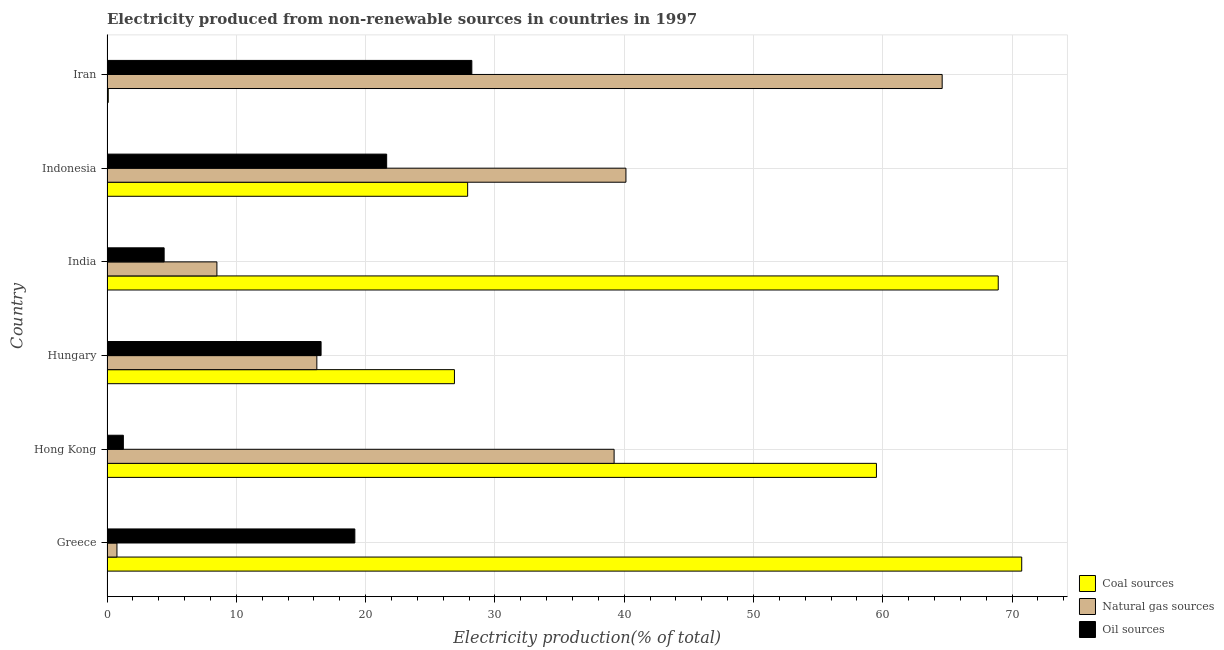Are the number of bars per tick equal to the number of legend labels?
Provide a short and direct response. Yes. Are the number of bars on each tick of the Y-axis equal?
Keep it short and to the point. Yes. How many bars are there on the 5th tick from the top?
Your answer should be compact. 3. How many bars are there on the 3rd tick from the bottom?
Provide a short and direct response. 3. What is the percentage of electricity produced by oil sources in Iran?
Your response must be concise. 28.22. Across all countries, what is the maximum percentage of electricity produced by natural gas?
Ensure brevity in your answer.  64.6. Across all countries, what is the minimum percentage of electricity produced by oil sources?
Give a very brief answer. 1.26. In which country was the percentage of electricity produced by coal maximum?
Offer a terse response. Greece. In which country was the percentage of electricity produced by natural gas minimum?
Provide a succinct answer. Greece. What is the total percentage of electricity produced by coal in the graph?
Make the answer very short. 254.06. What is the difference between the percentage of electricity produced by coal in Hong Kong and that in Iran?
Offer a very short reply. 59.41. What is the difference between the percentage of electricity produced by natural gas in Iran and the percentage of electricity produced by coal in India?
Provide a succinct answer. -4.34. What is the average percentage of electricity produced by oil sources per country?
Your response must be concise. 15.21. What is the difference between the percentage of electricity produced by natural gas and percentage of electricity produced by coal in Greece?
Your answer should be compact. -69.98. What is the ratio of the percentage of electricity produced by coal in Greece to that in Hungary?
Give a very brief answer. 2.63. Is the percentage of electricity produced by natural gas in Hong Kong less than that in Indonesia?
Make the answer very short. Yes. Is the difference between the percentage of electricity produced by oil sources in Hungary and Iran greater than the difference between the percentage of electricity produced by coal in Hungary and Iran?
Your response must be concise. No. What is the difference between the highest and the second highest percentage of electricity produced by oil sources?
Make the answer very short. 6.59. What is the difference between the highest and the lowest percentage of electricity produced by oil sources?
Give a very brief answer. 26.95. In how many countries, is the percentage of electricity produced by oil sources greater than the average percentage of electricity produced by oil sources taken over all countries?
Keep it short and to the point. 4. What does the 3rd bar from the top in India represents?
Provide a short and direct response. Coal sources. What does the 3rd bar from the bottom in Indonesia represents?
Provide a succinct answer. Oil sources. How many bars are there?
Offer a very short reply. 18. Are all the bars in the graph horizontal?
Provide a short and direct response. Yes. How many countries are there in the graph?
Give a very brief answer. 6. Are the values on the major ticks of X-axis written in scientific E-notation?
Your answer should be compact. No. Does the graph contain any zero values?
Ensure brevity in your answer.  No. How are the legend labels stacked?
Provide a succinct answer. Vertical. What is the title of the graph?
Your answer should be compact. Electricity produced from non-renewable sources in countries in 1997. Does "Hydroelectric sources" appear as one of the legend labels in the graph?
Ensure brevity in your answer.  No. What is the Electricity production(% of total) in Coal sources in Greece?
Your response must be concise. 70.75. What is the Electricity production(% of total) of Natural gas sources in Greece?
Your answer should be very brief. 0.77. What is the Electricity production(% of total) of Oil sources in Greece?
Make the answer very short. 19.17. What is the Electricity production(% of total) in Coal sources in Hong Kong?
Make the answer very short. 59.51. What is the Electricity production(% of total) of Natural gas sources in Hong Kong?
Your answer should be compact. 39.22. What is the Electricity production(% of total) of Oil sources in Hong Kong?
Provide a short and direct response. 1.26. What is the Electricity production(% of total) in Coal sources in Hungary?
Your answer should be compact. 26.87. What is the Electricity production(% of total) of Natural gas sources in Hungary?
Offer a very short reply. 16.23. What is the Electricity production(% of total) in Oil sources in Hungary?
Give a very brief answer. 16.56. What is the Electricity production(% of total) in Coal sources in India?
Keep it short and to the point. 68.93. What is the Electricity production(% of total) of Natural gas sources in India?
Ensure brevity in your answer.  8.5. What is the Electricity production(% of total) in Oil sources in India?
Make the answer very short. 4.42. What is the Electricity production(% of total) in Coal sources in Indonesia?
Provide a succinct answer. 27.89. What is the Electricity production(% of total) of Natural gas sources in Indonesia?
Keep it short and to the point. 40.14. What is the Electricity production(% of total) of Oil sources in Indonesia?
Offer a very short reply. 21.63. What is the Electricity production(% of total) in Coal sources in Iran?
Offer a terse response. 0.1. What is the Electricity production(% of total) of Natural gas sources in Iran?
Your answer should be very brief. 64.6. What is the Electricity production(% of total) in Oil sources in Iran?
Provide a short and direct response. 28.22. Across all countries, what is the maximum Electricity production(% of total) in Coal sources?
Offer a very short reply. 70.75. Across all countries, what is the maximum Electricity production(% of total) of Natural gas sources?
Offer a terse response. 64.6. Across all countries, what is the maximum Electricity production(% of total) in Oil sources?
Offer a very short reply. 28.22. Across all countries, what is the minimum Electricity production(% of total) of Coal sources?
Provide a succinct answer. 0.1. Across all countries, what is the minimum Electricity production(% of total) of Natural gas sources?
Your answer should be very brief. 0.77. Across all countries, what is the minimum Electricity production(% of total) in Oil sources?
Give a very brief answer. 1.26. What is the total Electricity production(% of total) of Coal sources in the graph?
Offer a terse response. 254.06. What is the total Electricity production(% of total) in Natural gas sources in the graph?
Offer a very short reply. 169.46. What is the total Electricity production(% of total) of Oil sources in the graph?
Provide a succinct answer. 91.26. What is the difference between the Electricity production(% of total) of Coal sources in Greece and that in Hong Kong?
Your answer should be compact. 11.24. What is the difference between the Electricity production(% of total) of Natural gas sources in Greece and that in Hong Kong?
Offer a terse response. -38.45. What is the difference between the Electricity production(% of total) of Oil sources in Greece and that in Hong Kong?
Keep it short and to the point. 17.91. What is the difference between the Electricity production(% of total) in Coal sources in Greece and that in Hungary?
Offer a very short reply. 43.88. What is the difference between the Electricity production(% of total) in Natural gas sources in Greece and that in Hungary?
Provide a short and direct response. -15.46. What is the difference between the Electricity production(% of total) of Oil sources in Greece and that in Hungary?
Your answer should be very brief. 2.61. What is the difference between the Electricity production(% of total) of Coal sources in Greece and that in India?
Your answer should be compact. 1.82. What is the difference between the Electricity production(% of total) of Natural gas sources in Greece and that in India?
Give a very brief answer. -7.73. What is the difference between the Electricity production(% of total) of Oil sources in Greece and that in India?
Keep it short and to the point. 14.75. What is the difference between the Electricity production(% of total) in Coal sources in Greece and that in Indonesia?
Offer a terse response. 42.86. What is the difference between the Electricity production(% of total) of Natural gas sources in Greece and that in Indonesia?
Your answer should be very brief. -39.37. What is the difference between the Electricity production(% of total) of Oil sources in Greece and that in Indonesia?
Your answer should be very brief. -2.46. What is the difference between the Electricity production(% of total) in Coal sources in Greece and that in Iran?
Provide a short and direct response. 70.65. What is the difference between the Electricity production(% of total) in Natural gas sources in Greece and that in Iran?
Give a very brief answer. -63.83. What is the difference between the Electricity production(% of total) in Oil sources in Greece and that in Iran?
Provide a short and direct response. -9.05. What is the difference between the Electricity production(% of total) of Coal sources in Hong Kong and that in Hungary?
Make the answer very short. 32.64. What is the difference between the Electricity production(% of total) in Natural gas sources in Hong Kong and that in Hungary?
Keep it short and to the point. 22.99. What is the difference between the Electricity production(% of total) of Oil sources in Hong Kong and that in Hungary?
Your answer should be compact. -15.29. What is the difference between the Electricity production(% of total) in Coal sources in Hong Kong and that in India?
Offer a very short reply. -9.42. What is the difference between the Electricity production(% of total) in Natural gas sources in Hong Kong and that in India?
Give a very brief answer. 30.72. What is the difference between the Electricity production(% of total) in Oil sources in Hong Kong and that in India?
Provide a succinct answer. -3.15. What is the difference between the Electricity production(% of total) in Coal sources in Hong Kong and that in Indonesia?
Your answer should be compact. 31.62. What is the difference between the Electricity production(% of total) in Natural gas sources in Hong Kong and that in Indonesia?
Provide a short and direct response. -0.91. What is the difference between the Electricity production(% of total) of Oil sources in Hong Kong and that in Indonesia?
Provide a succinct answer. -20.37. What is the difference between the Electricity production(% of total) of Coal sources in Hong Kong and that in Iran?
Provide a short and direct response. 59.41. What is the difference between the Electricity production(% of total) of Natural gas sources in Hong Kong and that in Iran?
Your answer should be compact. -25.37. What is the difference between the Electricity production(% of total) of Oil sources in Hong Kong and that in Iran?
Make the answer very short. -26.95. What is the difference between the Electricity production(% of total) in Coal sources in Hungary and that in India?
Your response must be concise. -42.06. What is the difference between the Electricity production(% of total) of Natural gas sources in Hungary and that in India?
Keep it short and to the point. 7.73. What is the difference between the Electricity production(% of total) in Oil sources in Hungary and that in India?
Make the answer very short. 12.14. What is the difference between the Electricity production(% of total) in Coal sources in Hungary and that in Indonesia?
Your response must be concise. -1.02. What is the difference between the Electricity production(% of total) in Natural gas sources in Hungary and that in Indonesia?
Make the answer very short. -23.91. What is the difference between the Electricity production(% of total) of Oil sources in Hungary and that in Indonesia?
Give a very brief answer. -5.07. What is the difference between the Electricity production(% of total) of Coal sources in Hungary and that in Iran?
Offer a terse response. 26.77. What is the difference between the Electricity production(% of total) of Natural gas sources in Hungary and that in Iran?
Provide a succinct answer. -48.37. What is the difference between the Electricity production(% of total) of Oil sources in Hungary and that in Iran?
Your answer should be compact. -11.66. What is the difference between the Electricity production(% of total) of Coal sources in India and that in Indonesia?
Provide a short and direct response. 41.04. What is the difference between the Electricity production(% of total) in Natural gas sources in India and that in Indonesia?
Provide a short and direct response. -31.64. What is the difference between the Electricity production(% of total) of Oil sources in India and that in Indonesia?
Ensure brevity in your answer.  -17.21. What is the difference between the Electricity production(% of total) of Coal sources in India and that in Iran?
Keep it short and to the point. 68.83. What is the difference between the Electricity production(% of total) in Natural gas sources in India and that in Iran?
Ensure brevity in your answer.  -56.1. What is the difference between the Electricity production(% of total) in Oil sources in India and that in Iran?
Ensure brevity in your answer.  -23.8. What is the difference between the Electricity production(% of total) in Coal sources in Indonesia and that in Iran?
Offer a very short reply. 27.8. What is the difference between the Electricity production(% of total) in Natural gas sources in Indonesia and that in Iran?
Provide a succinct answer. -24.46. What is the difference between the Electricity production(% of total) in Oil sources in Indonesia and that in Iran?
Offer a very short reply. -6.59. What is the difference between the Electricity production(% of total) in Coal sources in Greece and the Electricity production(% of total) in Natural gas sources in Hong Kong?
Offer a very short reply. 31.53. What is the difference between the Electricity production(% of total) of Coal sources in Greece and the Electricity production(% of total) of Oil sources in Hong Kong?
Your response must be concise. 69.49. What is the difference between the Electricity production(% of total) of Natural gas sources in Greece and the Electricity production(% of total) of Oil sources in Hong Kong?
Give a very brief answer. -0.5. What is the difference between the Electricity production(% of total) in Coal sources in Greece and the Electricity production(% of total) in Natural gas sources in Hungary?
Keep it short and to the point. 54.52. What is the difference between the Electricity production(% of total) of Coal sources in Greece and the Electricity production(% of total) of Oil sources in Hungary?
Provide a short and direct response. 54.19. What is the difference between the Electricity production(% of total) of Natural gas sources in Greece and the Electricity production(% of total) of Oil sources in Hungary?
Keep it short and to the point. -15.79. What is the difference between the Electricity production(% of total) of Coal sources in Greece and the Electricity production(% of total) of Natural gas sources in India?
Provide a succinct answer. 62.25. What is the difference between the Electricity production(% of total) of Coal sources in Greece and the Electricity production(% of total) of Oil sources in India?
Provide a succinct answer. 66.33. What is the difference between the Electricity production(% of total) of Natural gas sources in Greece and the Electricity production(% of total) of Oil sources in India?
Give a very brief answer. -3.65. What is the difference between the Electricity production(% of total) of Coal sources in Greece and the Electricity production(% of total) of Natural gas sources in Indonesia?
Ensure brevity in your answer.  30.61. What is the difference between the Electricity production(% of total) in Coal sources in Greece and the Electricity production(% of total) in Oil sources in Indonesia?
Your response must be concise. 49.12. What is the difference between the Electricity production(% of total) in Natural gas sources in Greece and the Electricity production(% of total) in Oil sources in Indonesia?
Make the answer very short. -20.86. What is the difference between the Electricity production(% of total) of Coal sources in Greece and the Electricity production(% of total) of Natural gas sources in Iran?
Offer a terse response. 6.15. What is the difference between the Electricity production(% of total) in Coal sources in Greece and the Electricity production(% of total) in Oil sources in Iran?
Give a very brief answer. 42.53. What is the difference between the Electricity production(% of total) of Natural gas sources in Greece and the Electricity production(% of total) of Oil sources in Iran?
Provide a short and direct response. -27.45. What is the difference between the Electricity production(% of total) in Coal sources in Hong Kong and the Electricity production(% of total) in Natural gas sources in Hungary?
Your response must be concise. 43.28. What is the difference between the Electricity production(% of total) of Coal sources in Hong Kong and the Electricity production(% of total) of Oil sources in Hungary?
Provide a short and direct response. 42.95. What is the difference between the Electricity production(% of total) of Natural gas sources in Hong Kong and the Electricity production(% of total) of Oil sources in Hungary?
Provide a succinct answer. 22.66. What is the difference between the Electricity production(% of total) in Coal sources in Hong Kong and the Electricity production(% of total) in Natural gas sources in India?
Make the answer very short. 51.01. What is the difference between the Electricity production(% of total) in Coal sources in Hong Kong and the Electricity production(% of total) in Oil sources in India?
Ensure brevity in your answer.  55.09. What is the difference between the Electricity production(% of total) in Natural gas sources in Hong Kong and the Electricity production(% of total) in Oil sources in India?
Your response must be concise. 34.8. What is the difference between the Electricity production(% of total) in Coal sources in Hong Kong and the Electricity production(% of total) in Natural gas sources in Indonesia?
Provide a short and direct response. 19.38. What is the difference between the Electricity production(% of total) in Coal sources in Hong Kong and the Electricity production(% of total) in Oil sources in Indonesia?
Ensure brevity in your answer.  37.88. What is the difference between the Electricity production(% of total) in Natural gas sources in Hong Kong and the Electricity production(% of total) in Oil sources in Indonesia?
Ensure brevity in your answer.  17.59. What is the difference between the Electricity production(% of total) in Coal sources in Hong Kong and the Electricity production(% of total) in Natural gas sources in Iran?
Your answer should be very brief. -5.08. What is the difference between the Electricity production(% of total) in Coal sources in Hong Kong and the Electricity production(% of total) in Oil sources in Iran?
Offer a very short reply. 31.3. What is the difference between the Electricity production(% of total) of Natural gas sources in Hong Kong and the Electricity production(% of total) of Oil sources in Iran?
Your answer should be compact. 11.01. What is the difference between the Electricity production(% of total) of Coal sources in Hungary and the Electricity production(% of total) of Natural gas sources in India?
Provide a succinct answer. 18.37. What is the difference between the Electricity production(% of total) of Coal sources in Hungary and the Electricity production(% of total) of Oil sources in India?
Your answer should be very brief. 22.45. What is the difference between the Electricity production(% of total) of Natural gas sources in Hungary and the Electricity production(% of total) of Oil sources in India?
Offer a very short reply. 11.81. What is the difference between the Electricity production(% of total) of Coal sources in Hungary and the Electricity production(% of total) of Natural gas sources in Indonesia?
Provide a short and direct response. -13.26. What is the difference between the Electricity production(% of total) of Coal sources in Hungary and the Electricity production(% of total) of Oil sources in Indonesia?
Give a very brief answer. 5.24. What is the difference between the Electricity production(% of total) in Natural gas sources in Hungary and the Electricity production(% of total) in Oil sources in Indonesia?
Offer a terse response. -5.4. What is the difference between the Electricity production(% of total) in Coal sources in Hungary and the Electricity production(% of total) in Natural gas sources in Iran?
Provide a succinct answer. -37.72. What is the difference between the Electricity production(% of total) in Coal sources in Hungary and the Electricity production(% of total) in Oil sources in Iran?
Provide a short and direct response. -1.35. What is the difference between the Electricity production(% of total) in Natural gas sources in Hungary and the Electricity production(% of total) in Oil sources in Iran?
Your answer should be very brief. -11.99. What is the difference between the Electricity production(% of total) of Coal sources in India and the Electricity production(% of total) of Natural gas sources in Indonesia?
Offer a very short reply. 28.8. What is the difference between the Electricity production(% of total) of Coal sources in India and the Electricity production(% of total) of Oil sources in Indonesia?
Your answer should be compact. 47.3. What is the difference between the Electricity production(% of total) of Natural gas sources in India and the Electricity production(% of total) of Oil sources in Indonesia?
Your answer should be very brief. -13.13. What is the difference between the Electricity production(% of total) of Coal sources in India and the Electricity production(% of total) of Natural gas sources in Iran?
Make the answer very short. 4.34. What is the difference between the Electricity production(% of total) in Coal sources in India and the Electricity production(% of total) in Oil sources in Iran?
Your answer should be compact. 40.71. What is the difference between the Electricity production(% of total) of Natural gas sources in India and the Electricity production(% of total) of Oil sources in Iran?
Your answer should be compact. -19.72. What is the difference between the Electricity production(% of total) of Coal sources in Indonesia and the Electricity production(% of total) of Natural gas sources in Iran?
Offer a very short reply. -36.7. What is the difference between the Electricity production(% of total) in Coal sources in Indonesia and the Electricity production(% of total) in Oil sources in Iran?
Your answer should be very brief. -0.32. What is the difference between the Electricity production(% of total) in Natural gas sources in Indonesia and the Electricity production(% of total) in Oil sources in Iran?
Provide a short and direct response. 11.92. What is the average Electricity production(% of total) of Coal sources per country?
Give a very brief answer. 42.34. What is the average Electricity production(% of total) in Natural gas sources per country?
Give a very brief answer. 28.24. What is the average Electricity production(% of total) of Oil sources per country?
Offer a very short reply. 15.21. What is the difference between the Electricity production(% of total) of Coal sources and Electricity production(% of total) of Natural gas sources in Greece?
Your answer should be very brief. 69.98. What is the difference between the Electricity production(% of total) in Coal sources and Electricity production(% of total) in Oil sources in Greece?
Your answer should be very brief. 51.58. What is the difference between the Electricity production(% of total) in Natural gas sources and Electricity production(% of total) in Oil sources in Greece?
Your answer should be compact. -18.4. What is the difference between the Electricity production(% of total) of Coal sources and Electricity production(% of total) of Natural gas sources in Hong Kong?
Ensure brevity in your answer.  20.29. What is the difference between the Electricity production(% of total) of Coal sources and Electricity production(% of total) of Oil sources in Hong Kong?
Offer a very short reply. 58.25. What is the difference between the Electricity production(% of total) in Natural gas sources and Electricity production(% of total) in Oil sources in Hong Kong?
Your answer should be compact. 37.96. What is the difference between the Electricity production(% of total) in Coal sources and Electricity production(% of total) in Natural gas sources in Hungary?
Your answer should be very brief. 10.64. What is the difference between the Electricity production(% of total) in Coal sources and Electricity production(% of total) in Oil sources in Hungary?
Your answer should be very brief. 10.31. What is the difference between the Electricity production(% of total) of Natural gas sources and Electricity production(% of total) of Oil sources in Hungary?
Your answer should be very brief. -0.33. What is the difference between the Electricity production(% of total) in Coal sources and Electricity production(% of total) in Natural gas sources in India?
Give a very brief answer. 60.43. What is the difference between the Electricity production(% of total) of Coal sources and Electricity production(% of total) of Oil sources in India?
Provide a succinct answer. 64.51. What is the difference between the Electricity production(% of total) of Natural gas sources and Electricity production(% of total) of Oil sources in India?
Your answer should be very brief. 4.08. What is the difference between the Electricity production(% of total) in Coal sources and Electricity production(% of total) in Natural gas sources in Indonesia?
Offer a very short reply. -12.24. What is the difference between the Electricity production(% of total) in Coal sources and Electricity production(% of total) in Oil sources in Indonesia?
Your response must be concise. 6.26. What is the difference between the Electricity production(% of total) of Natural gas sources and Electricity production(% of total) of Oil sources in Indonesia?
Provide a short and direct response. 18.51. What is the difference between the Electricity production(% of total) of Coal sources and Electricity production(% of total) of Natural gas sources in Iran?
Your answer should be compact. -64.5. What is the difference between the Electricity production(% of total) in Coal sources and Electricity production(% of total) in Oil sources in Iran?
Your answer should be compact. -28.12. What is the difference between the Electricity production(% of total) in Natural gas sources and Electricity production(% of total) in Oil sources in Iran?
Give a very brief answer. 36.38. What is the ratio of the Electricity production(% of total) in Coal sources in Greece to that in Hong Kong?
Offer a very short reply. 1.19. What is the ratio of the Electricity production(% of total) in Natural gas sources in Greece to that in Hong Kong?
Give a very brief answer. 0.02. What is the ratio of the Electricity production(% of total) in Oil sources in Greece to that in Hong Kong?
Your response must be concise. 15.16. What is the ratio of the Electricity production(% of total) in Coal sources in Greece to that in Hungary?
Your answer should be very brief. 2.63. What is the ratio of the Electricity production(% of total) in Natural gas sources in Greece to that in Hungary?
Keep it short and to the point. 0.05. What is the ratio of the Electricity production(% of total) of Oil sources in Greece to that in Hungary?
Your answer should be very brief. 1.16. What is the ratio of the Electricity production(% of total) of Coal sources in Greece to that in India?
Offer a very short reply. 1.03. What is the ratio of the Electricity production(% of total) in Natural gas sources in Greece to that in India?
Provide a succinct answer. 0.09. What is the ratio of the Electricity production(% of total) of Oil sources in Greece to that in India?
Offer a terse response. 4.34. What is the ratio of the Electricity production(% of total) of Coal sources in Greece to that in Indonesia?
Your response must be concise. 2.54. What is the ratio of the Electricity production(% of total) in Natural gas sources in Greece to that in Indonesia?
Ensure brevity in your answer.  0.02. What is the ratio of the Electricity production(% of total) of Oil sources in Greece to that in Indonesia?
Provide a succinct answer. 0.89. What is the ratio of the Electricity production(% of total) in Coal sources in Greece to that in Iran?
Give a very brief answer. 720.51. What is the ratio of the Electricity production(% of total) of Natural gas sources in Greece to that in Iran?
Provide a short and direct response. 0.01. What is the ratio of the Electricity production(% of total) of Oil sources in Greece to that in Iran?
Your answer should be compact. 0.68. What is the ratio of the Electricity production(% of total) of Coal sources in Hong Kong to that in Hungary?
Ensure brevity in your answer.  2.21. What is the ratio of the Electricity production(% of total) in Natural gas sources in Hong Kong to that in Hungary?
Ensure brevity in your answer.  2.42. What is the ratio of the Electricity production(% of total) in Oil sources in Hong Kong to that in Hungary?
Offer a very short reply. 0.08. What is the ratio of the Electricity production(% of total) of Coal sources in Hong Kong to that in India?
Ensure brevity in your answer.  0.86. What is the ratio of the Electricity production(% of total) in Natural gas sources in Hong Kong to that in India?
Your answer should be compact. 4.61. What is the ratio of the Electricity production(% of total) of Oil sources in Hong Kong to that in India?
Provide a short and direct response. 0.29. What is the ratio of the Electricity production(% of total) in Coal sources in Hong Kong to that in Indonesia?
Your response must be concise. 2.13. What is the ratio of the Electricity production(% of total) in Natural gas sources in Hong Kong to that in Indonesia?
Keep it short and to the point. 0.98. What is the ratio of the Electricity production(% of total) of Oil sources in Hong Kong to that in Indonesia?
Provide a short and direct response. 0.06. What is the ratio of the Electricity production(% of total) in Coal sources in Hong Kong to that in Iran?
Provide a succinct answer. 606.07. What is the ratio of the Electricity production(% of total) in Natural gas sources in Hong Kong to that in Iran?
Give a very brief answer. 0.61. What is the ratio of the Electricity production(% of total) of Oil sources in Hong Kong to that in Iran?
Give a very brief answer. 0.04. What is the ratio of the Electricity production(% of total) of Coal sources in Hungary to that in India?
Your response must be concise. 0.39. What is the ratio of the Electricity production(% of total) in Natural gas sources in Hungary to that in India?
Provide a short and direct response. 1.91. What is the ratio of the Electricity production(% of total) in Oil sources in Hungary to that in India?
Give a very brief answer. 3.75. What is the ratio of the Electricity production(% of total) in Coal sources in Hungary to that in Indonesia?
Offer a very short reply. 0.96. What is the ratio of the Electricity production(% of total) in Natural gas sources in Hungary to that in Indonesia?
Offer a terse response. 0.4. What is the ratio of the Electricity production(% of total) of Oil sources in Hungary to that in Indonesia?
Keep it short and to the point. 0.77. What is the ratio of the Electricity production(% of total) in Coal sources in Hungary to that in Iran?
Ensure brevity in your answer.  273.66. What is the ratio of the Electricity production(% of total) in Natural gas sources in Hungary to that in Iran?
Your answer should be compact. 0.25. What is the ratio of the Electricity production(% of total) of Oil sources in Hungary to that in Iran?
Make the answer very short. 0.59. What is the ratio of the Electricity production(% of total) in Coal sources in India to that in Indonesia?
Keep it short and to the point. 2.47. What is the ratio of the Electricity production(% of total) in Natural gas sources in India to that in Indonesia?
Ensure brevity in your answer.  0.21. What is the ratio of the Electricity production(% of total) in Oil sources in India to that in Indonesia?
Make the answer very short. 0.2. What is the ratio of the Electricity production(% of total) of Coal sources in India to that in Iran?
Offer a terse response. 702. What is the ratio of the Electricity production(% of total) in Natural gas sources in India to that in Iran?
Provide a succinct answer. 0.13. What is the ratio of the Electricity production(% of total) of Oil sources in India to that in Iran?
Keep it short and to the point. 0.16. What is the ratio of the Electricity production(% of total) of Coal sources in Indonesia to that in Iran?
Keep it short and to the point. 284.06. What is the ratio of the Electricity production(% of total) in Natural gas sources in Indonesia to that in Iran?
Provide a short and direct response. 0.62. What is the ratio of the Electricity production(% of total) of Oil sources in Indonesia to that in Iran?
Offer a terse response. 0.77. What is the difference between the highest and the second highest Electricity production(% of total) in Coal sources?
Offer a terse response. 1.82. What is the difference between the highest and the second highest Electricity production(% of total) in Natural gas sources?
Your answer should be compact. 24.46. What is the difference between the highest and the second highest Electricity production(% of total) of Oil sources?
Provide a succinct answer. 6.59. What is the difference between the highest and the lowest Electricity production(% of total) in Coal sources?
Provide a short and direct response. 70.65. What is the difference between the highest and the lowest Electricity production(% of total) of Natural gas sources?
Provide a succinct answer. 63.83. What is the difference between the highest and the lowest Electricity production(% of total) of Oil sources?
Make the answer very short. 26.95. 